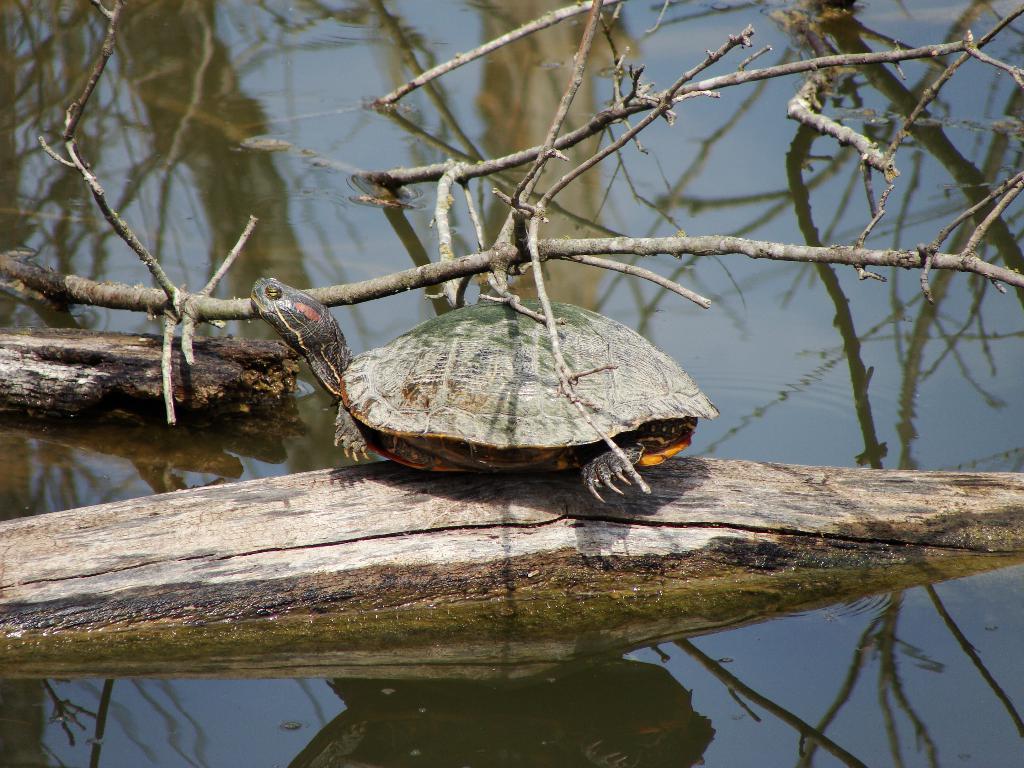Please provide a concise description of this image. In this image we can see a tortoise on a wooden log and some branches of a tree in a water body. 